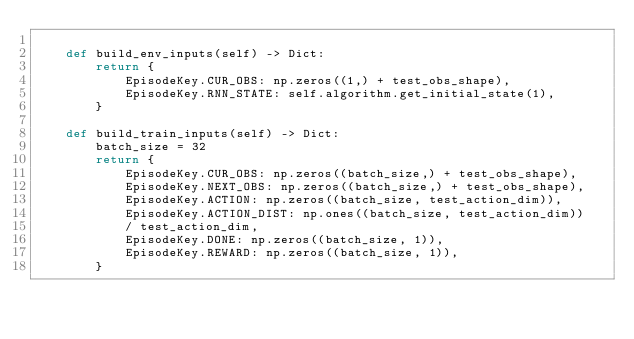Convert code to text. <code><loc_0><loc_0><loc_500><loc_500><_Python_>
    def build_env_inputs(self) -> Dict:
        return {
            EpisodeKey.CUR_OBS: np.zeros((1,) + test_obs_shape),
            EpisodeKey.RNN_STATE: self.algorithm.get_initial_state(1),
        }

    def build_train_inputs(self) -> Dict:
        batch_size = 32
        return {
            EpisodeKey.CUR_OBS: np.zeros((batch_size,) + test_obs_shape),
            EpisodeKey.NEXT_OBS: np.zeros((batch_size,) + test_obs_shape),
            EpisodeKey.ACTION: np.zeros((batch_size, test_action_dim)),
            EpisodeKey.ACTION_DIST: np.ones((batch_size, test_action_dim))
            / test_action_dim,
            EpisodeKey.DONE: np.zeros((batch_size, 1)),
            EpisodeKey.REWARD: np.zeros((batch_size, 1)),
        }
</code> 